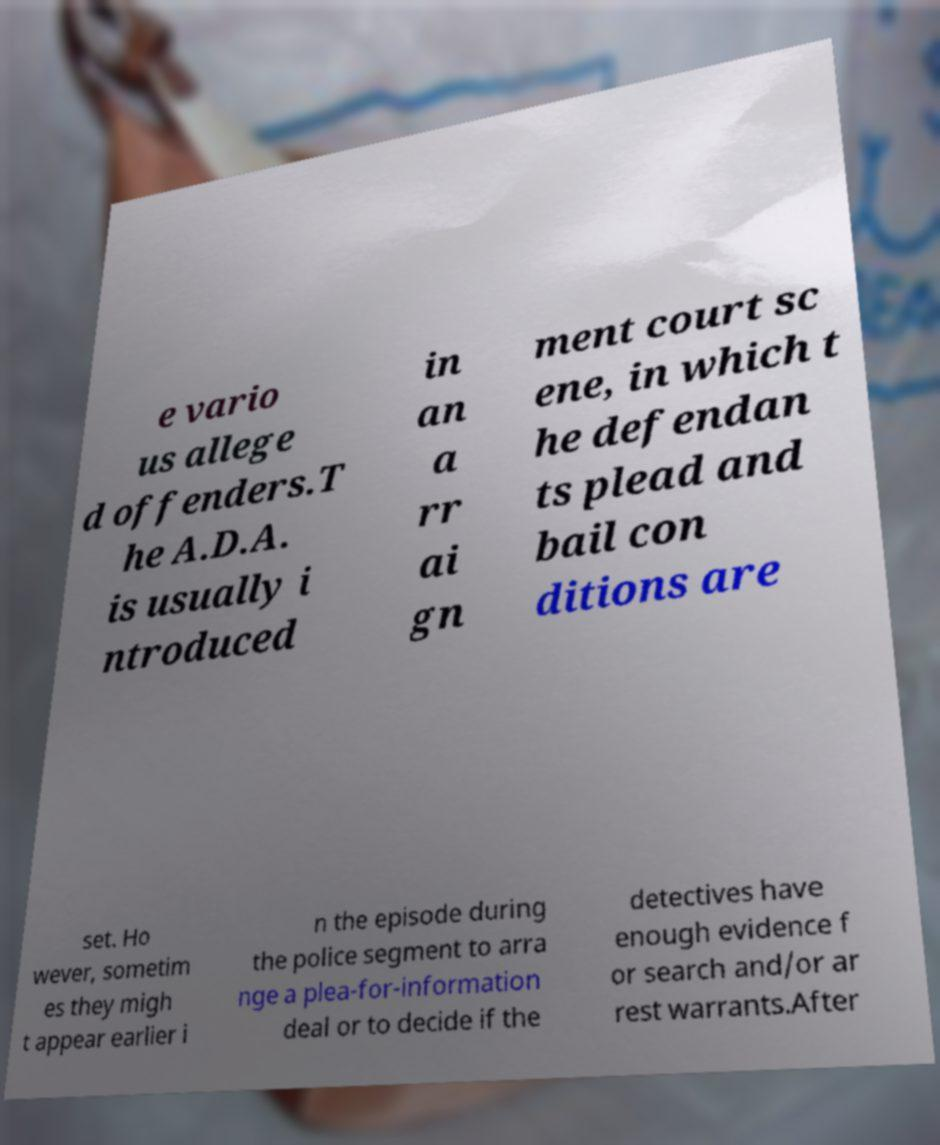For documentation purposes, I need the text within this image transcribed. Could you provide that? e vario us allege d offenders.T he A.D.A. is usually i ntroduced in an a rr ai gn ment court sc ene, in which t he defendan ts plead and bail con ditions are set. Ho wever, sometim es they migh t appear earlier i n the episode during the police segment to arra nge a plea-for-information deal or to decide if the detectives have enough evidence f or search and/or ar rest warrants.After 